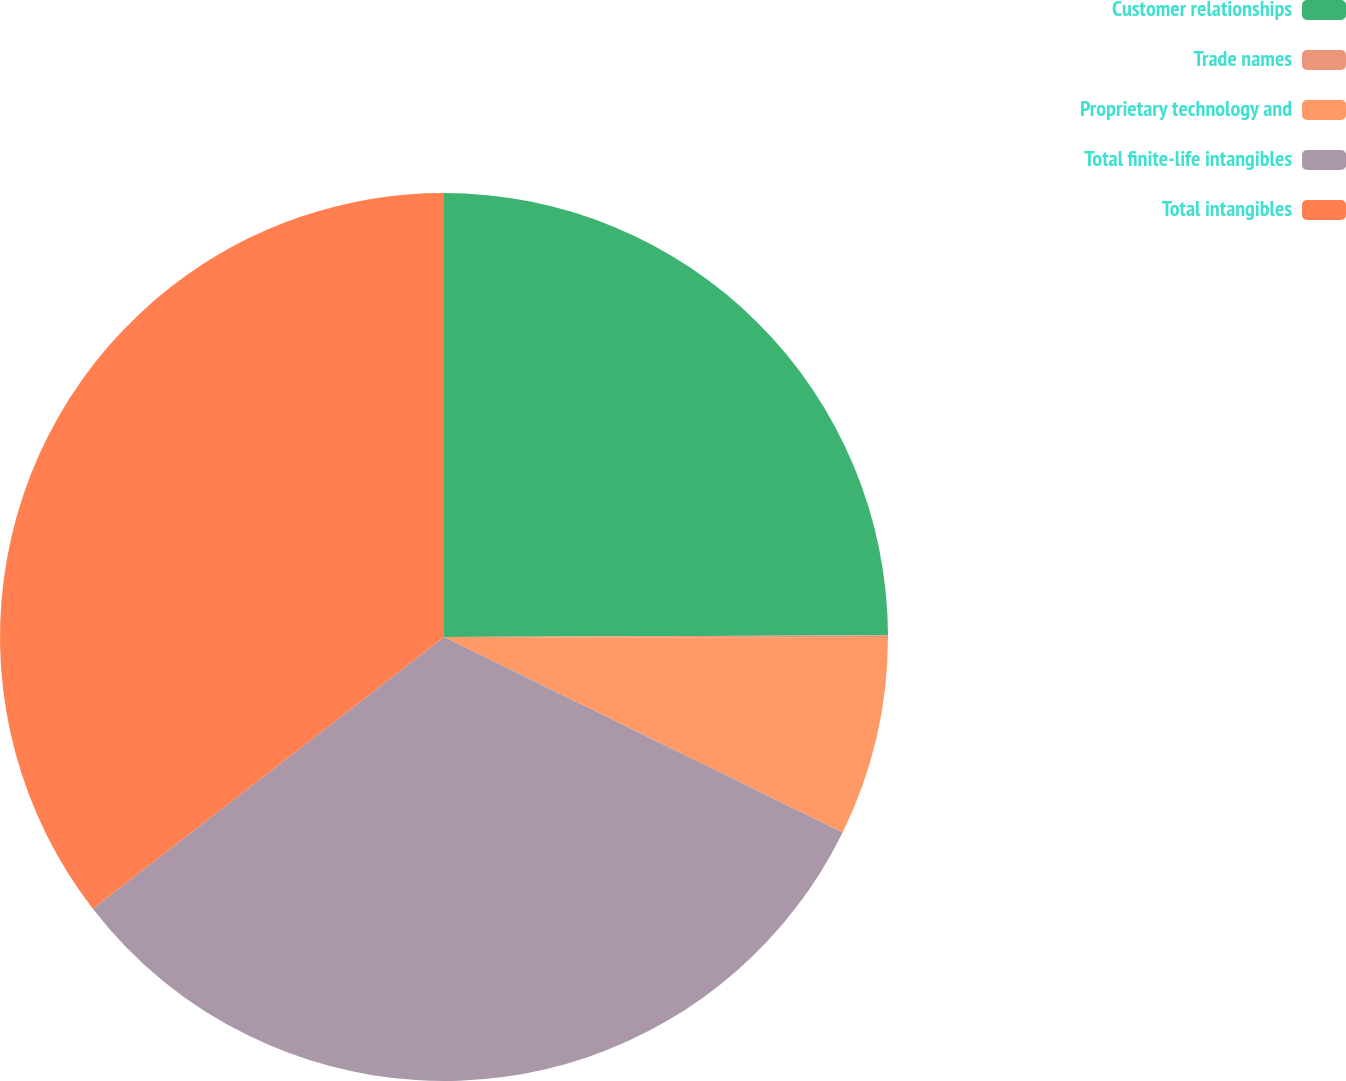<chart> <loc_0><loc_0><loc_500><loc_500><pie_chart><fcel>Customer relationships<fcel>Trade names<fcel>Proprietary technology and<fcel>Total finite-life intangibles<fcel>Total intangibles<nl><fcel>24.94%<fcel>0.1%<fcel>7.22%<fcel>32.26%<fcel>35.48%<nl></chart> 